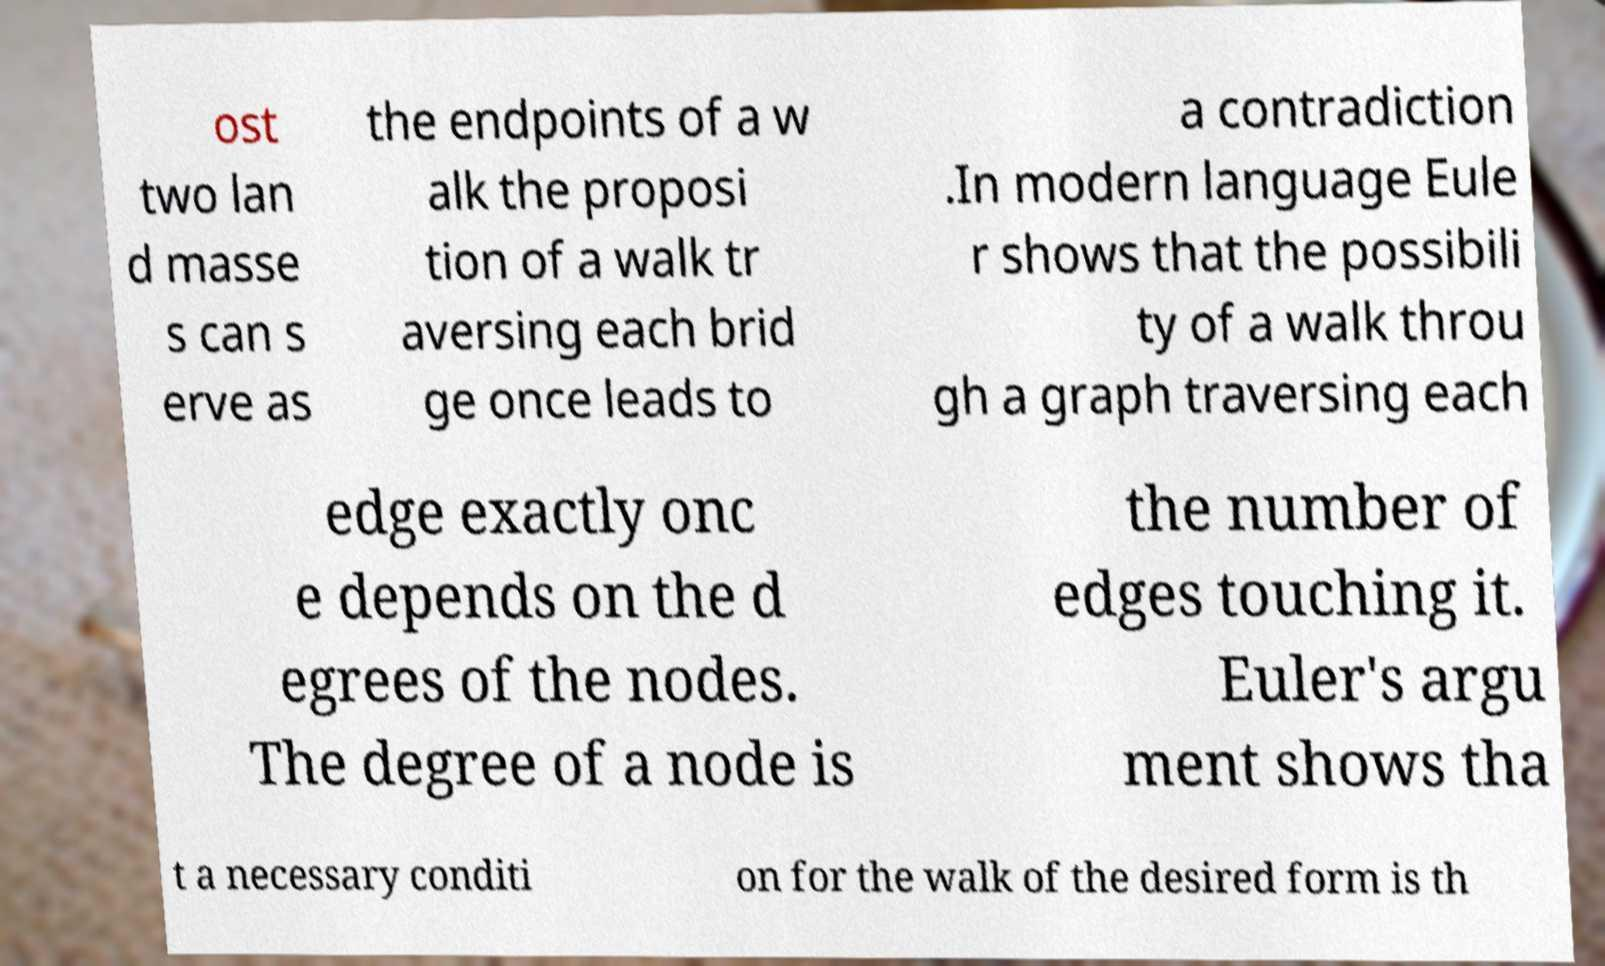Please identify and transcribe the text found in this image. ost two lan d masse s can s erve as the endpoints of a w alk the proposi tion of a walk tr aversing each brid ge once leads to a contradiction .In modern language Eule r shows that the possibili ty of a walk throu gh a graph traversing each edge exactly onc e depends on the d egrees of the nodes. The degree of a node is the number of edges touching it. Euler's argu ment shows tha t a necessary conditi on for the walk of the desired form is th 